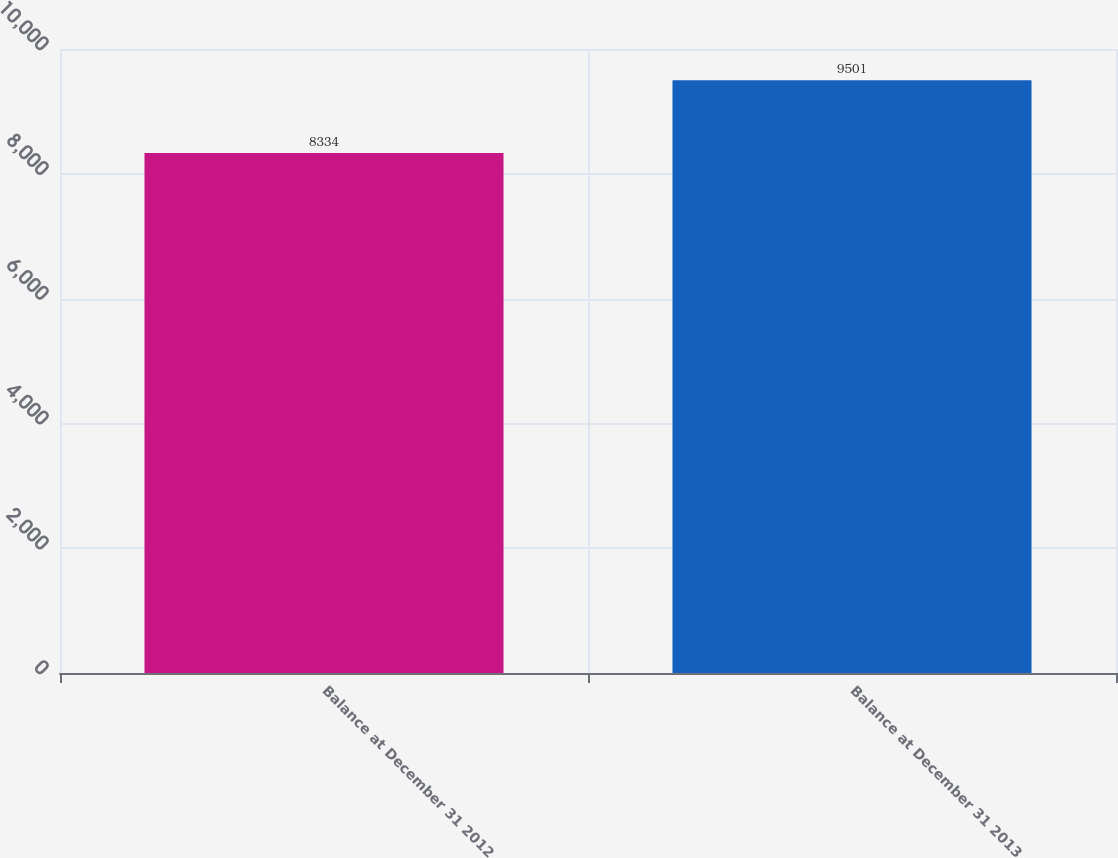<chart> <loc_0><loc_0><loc_500><loc_500><bar_chart><fcel>Balance at December 31 2012<fcel>Balance at December 31 2013<nl><fcel>8334<fcel>9501<nl></chart> 